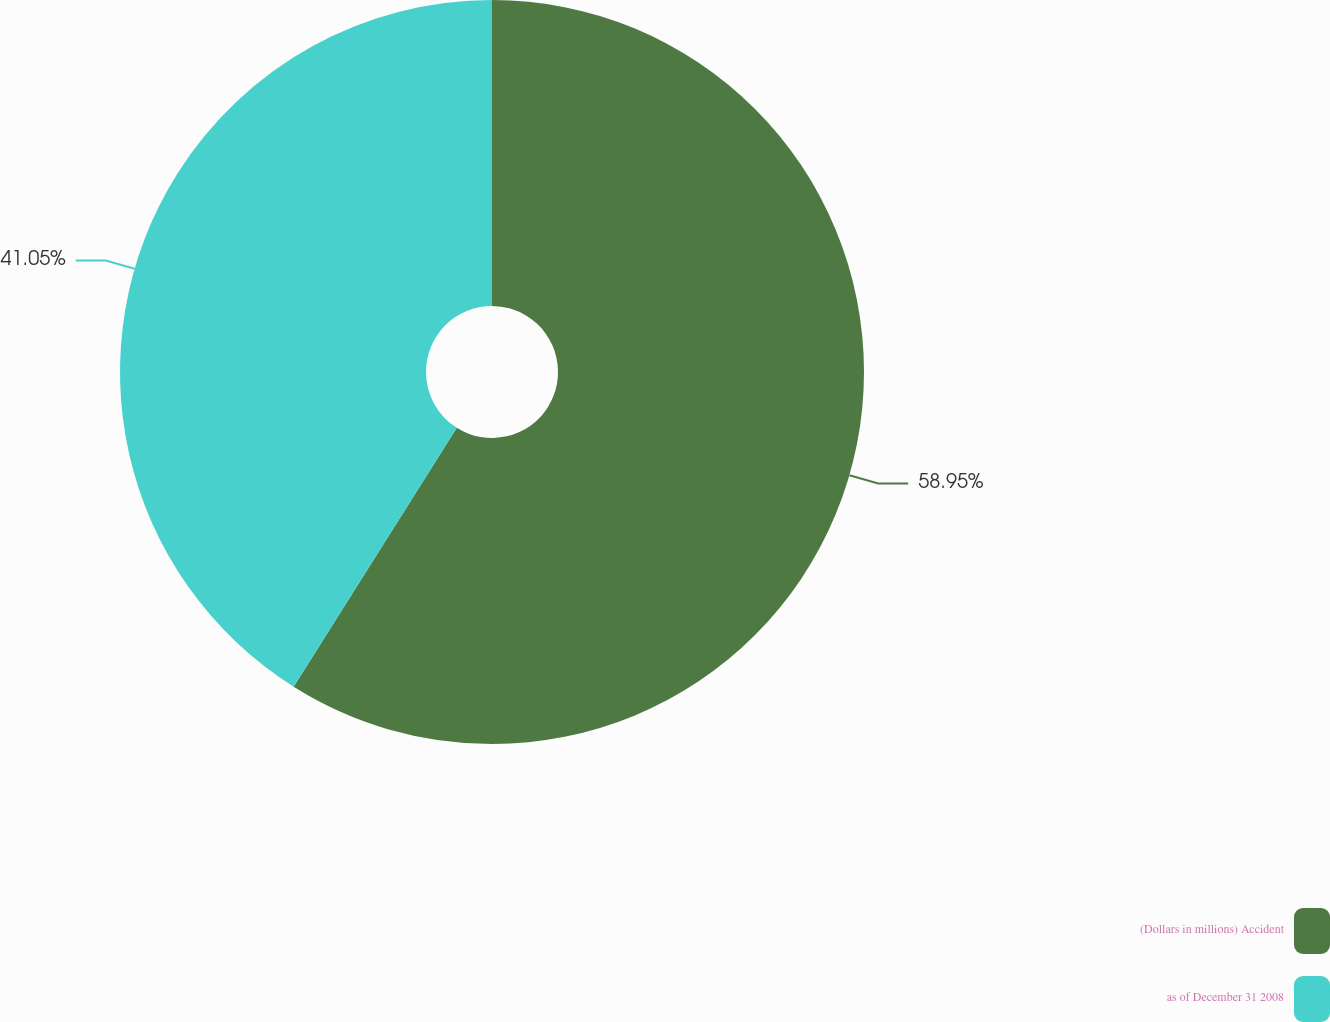Convert chart. <chart><loc_0><loc_0><loc_500><loc_500><pie_chart><fcel>(Dollars in millions) Accident<fcel>as of December 31 2008<nl><fcel>58.95%<fcel>41.05%<nl></chart> 